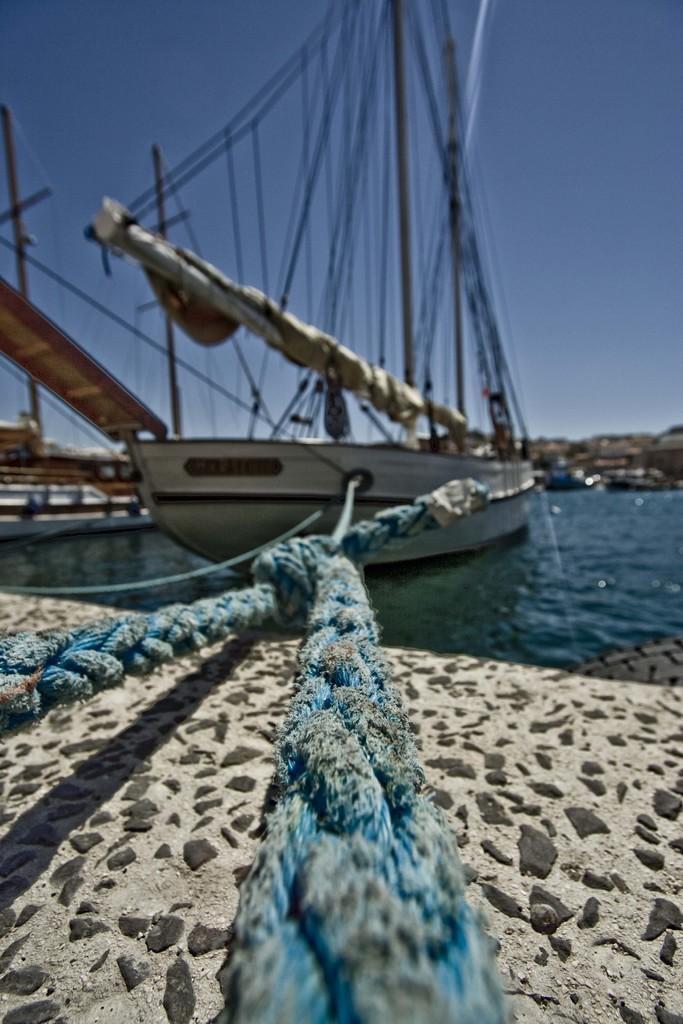Please provide a concise description of this image. In the image there are two ropes tied to a ship on the water surface and under the ropes there is a sand surface, there are a lot of threads tied to the pole on the ship. 